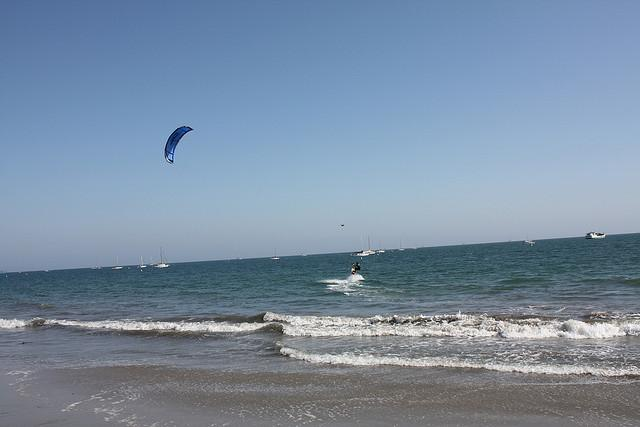The shape of the paragliding inflatable wing is? curved 